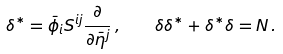Convert formula to latex. <formula><loc_0><loc_0><loc_500><loc_500>\delta ^ { \ast } = \bar { \phi } _ { i } S ^ { i j } \frac { \partial } { \partial \bar { \eta } ^ { j } } \, , \quad \delta \delta ^ { \ast } + \delta ^ { \ast } \delta = N \, .</formula> 